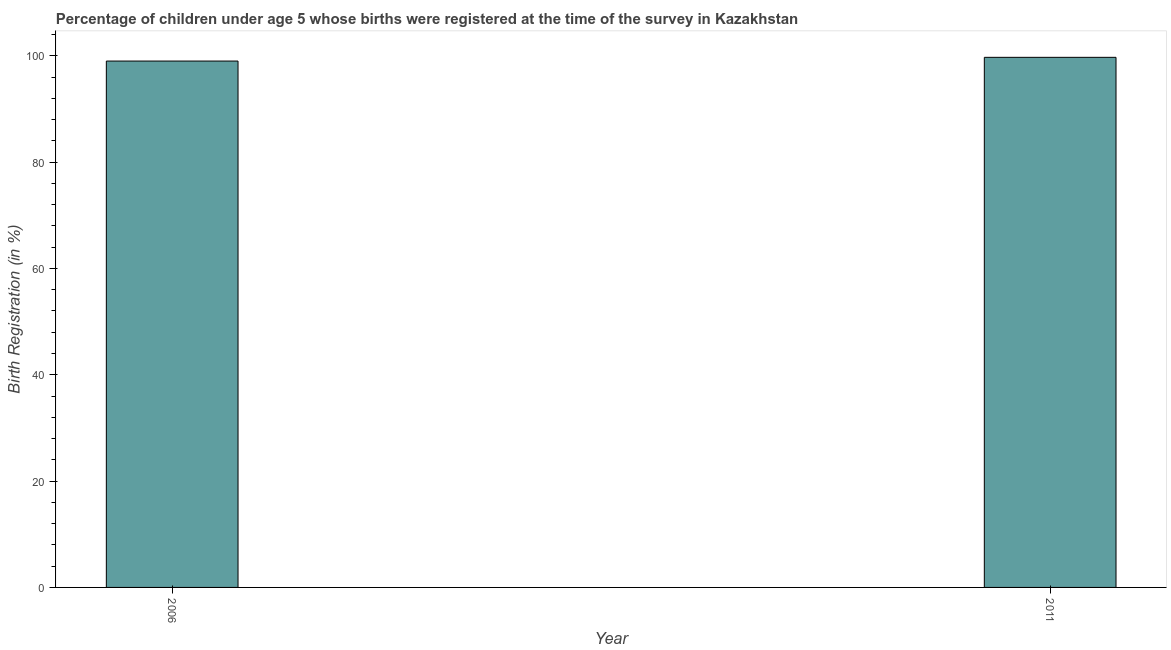What is the title of the graph?
Your answer should be compact. Percentage of children under age 5 whose births were registered at the time of the survey in Kazakhstan. What is the label or title of the X-axis?
Offer a very short reply. Year. What is the label or title of the Y-axis?
Your response must be concise. Birth Registration (in %). Across all years, what is the maximum birth registration?
Ensure brevity in your answer.  99.7. In which year was the birth registration maximum?
Give a very brief answer. 2011. What is the sum of the birth registration?
Offer a very short reply. 198.7. What is the average birth registration per year?
Keep it short and to the point. 99.35. What is the median birth registration?
Your answer should be very brief. 99.35. In how many years, is the birth registration greater than 44 %?
Your answer should be compact. 2. In how many years, is the birth registration greater than the average birth registration taken over all years?
Offer a terse response. 1. Are all the bars in the graph horizontal?
Keep it short and to the point. No. How many years are there in the graph?
Your answer should be compact. 2. What is the difference between two consecutive major ticks on the Y-axis?
Give a very brief answer. 20. What is the Birth Registration (in %) in 2006?
Offer a very short reply. 99. What is the Birth Registration (in %) of 2011?
Your answer should be very brief. 99.7. 